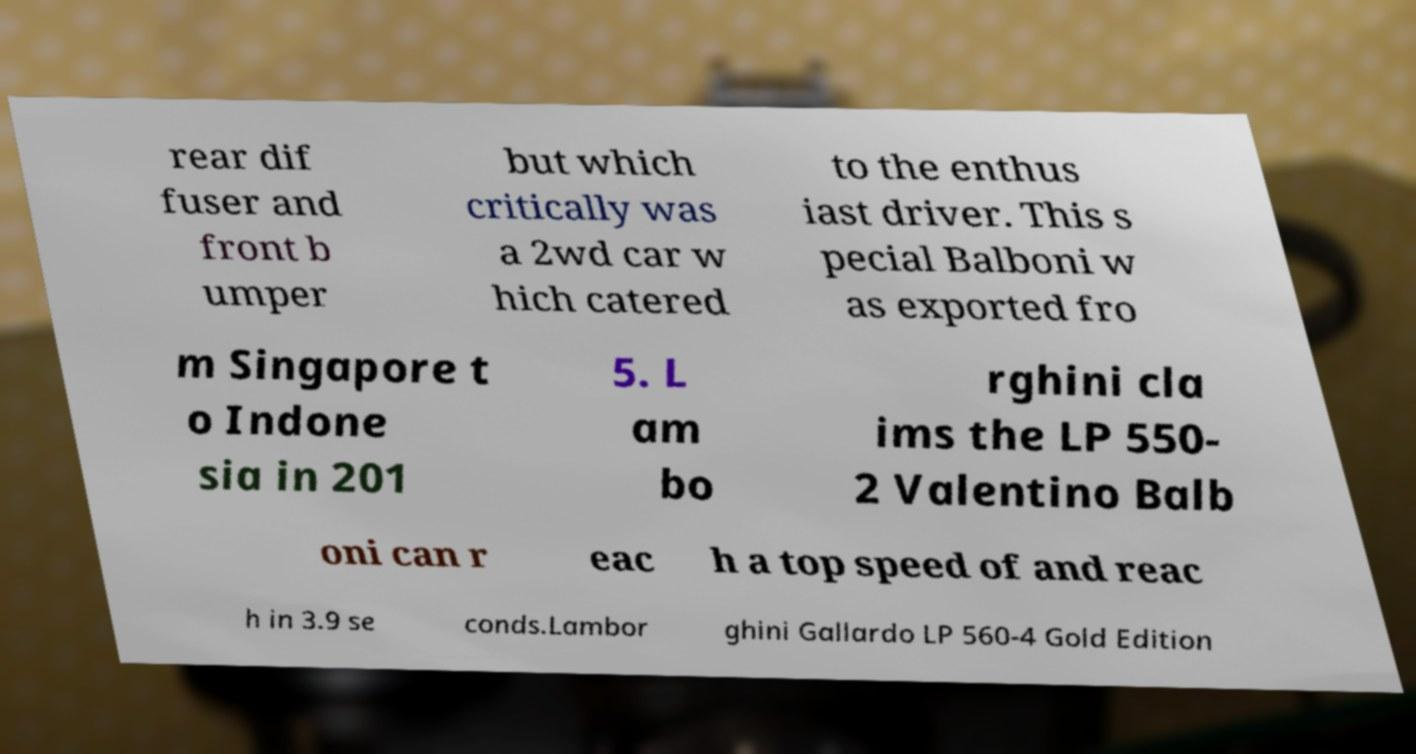Can you read and provide the text displayed in the image?This photo seems to have some interesting text. Can you extract and type it out for me? rear dif fuser and front b umper but which critically was a 2wd car w hich catered to the enthus iast driver. This s pecial Balboni w as exported fro m Singapore t o Indone sia in 201 5. L am bo rghini cla ims the LP 550- 2 Valentino Balb oni can r eac h a top speed of and reac h in 3.9 se conds.Lambor ghini Gallardo LP 560-4 Gold Edition 